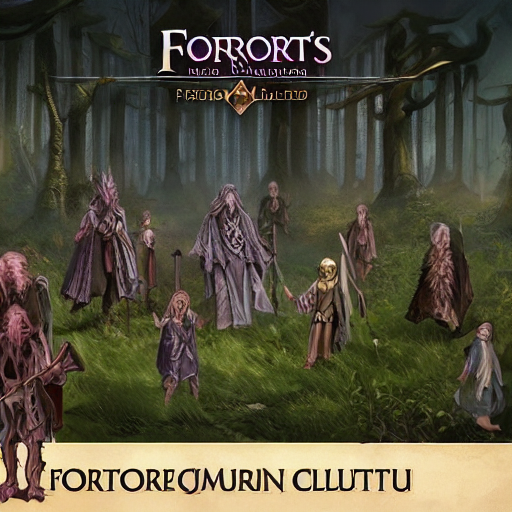What can you say about the quality of this image?
A. Poor
B. Excellent
C. Good The image quality could be subjectively deemed as 'poor' due to the perceived lack of sharpness, detail, or possible digital artifacts. This assessment could hinge on several factors such as resolution, composition, color balance, and the presence of noise. It's important to consider that the artistic intention behind the image may intentionally include a certain aesthetic that does not align with conventional 'high-quality' criteria. 